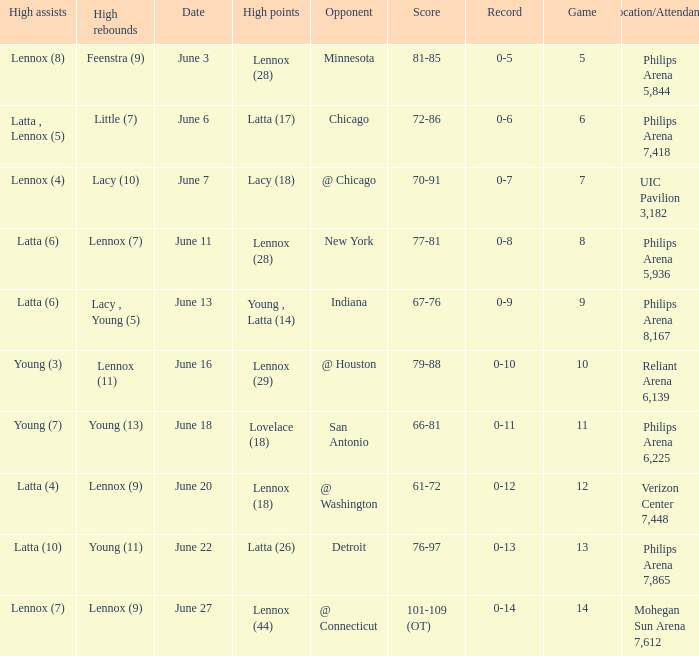Who made the highest assist in the game that scored 79-88? Young (3). 